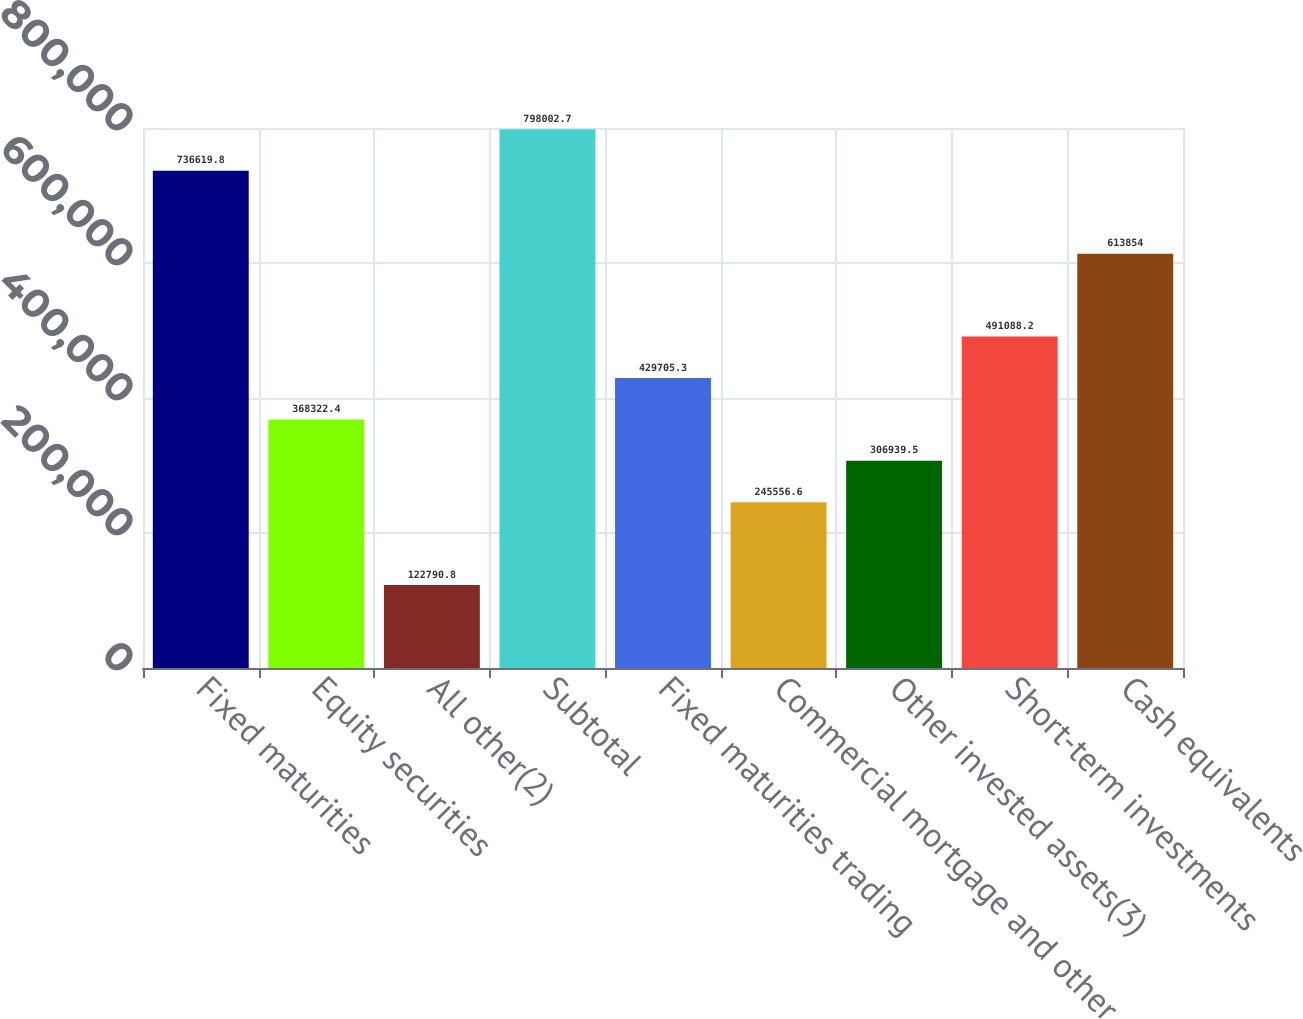Convert chart to OTSL. <chart><loc_0><loc_0><loc_500><loc_500><bar_chart><fcel>Fixed maturities<fcel>Equity securities<fcel>All other(2)<fcel>Subtotal<fcel>Fixed maturities trading<fcel>Commercial mortgage and other<fcel>Other invested assets(3)<fcel>Short-term investments<fcel>Cash equivalents<nl><fcel>736620<fcel>368322<fcel>122791<fcel>798003<fcel>429705<fcel>245557<fcel>306940<fcel>491088<fcel>613854<nl></chart> 